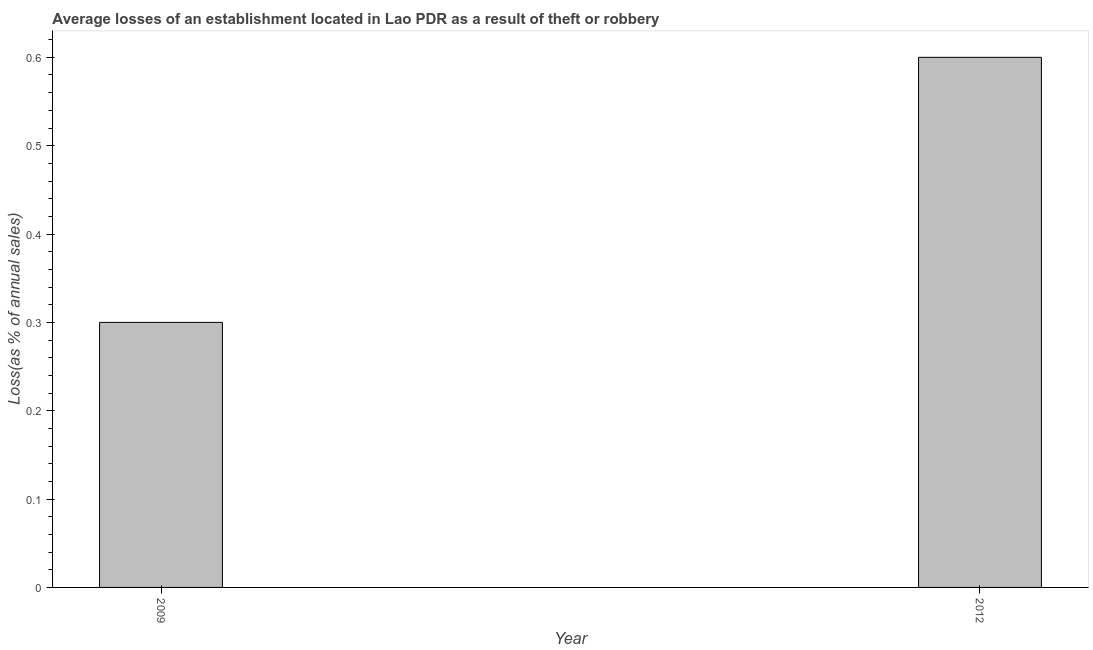What is the title of the graph?
Your answer should be compact. Average losses of an establishment located in Lao PDR as a result of theft or robbery. What is the label or title of the Y-axis?
Offer a terse response. Loss(as % of annual sales). What is the losses due to theft in 2012?
Keep it short and to the point. 0.6. Across all years, what is the minimum losses due to theft?
Your answer should be very brief. 0.3. What is the sum of the losses due to theft?
Provide a short and direct response. 0.9. What is the difference between the losses due to theft in 2009 and 2012?
Provide a short and direct response. -0.3. What is the average losses due to theft per year?
Keep it short and to the point. 0.45. What is the median losses due to theft?
Give a very brief answer. 0.45. Do a majority of the years between 2009 and 2012 (inclusive) have losses due to theft greater than 0.46 %?
Your answer should be very brief. No. Is the losses due to theft in 2009 less than that in 2012?
Offer a very short reply. Yes. In how many years, is the losses due to theft greater than the average losses due to theft taken over all years?
Your answer should be very brief. 1. How many years are there in the graph?
Your answer should be very brief. 2. What is the difference between two consecutive major ticks on the Y-axis?
Your answer should be very brief. 0.1. Are the values on the major ticks of Y-axis written in scientific E-notation?
Keep it short and to the point. No. What is the Loss(as % of annual sales) in 2009?
Provide a short and direct response. 0.3. 